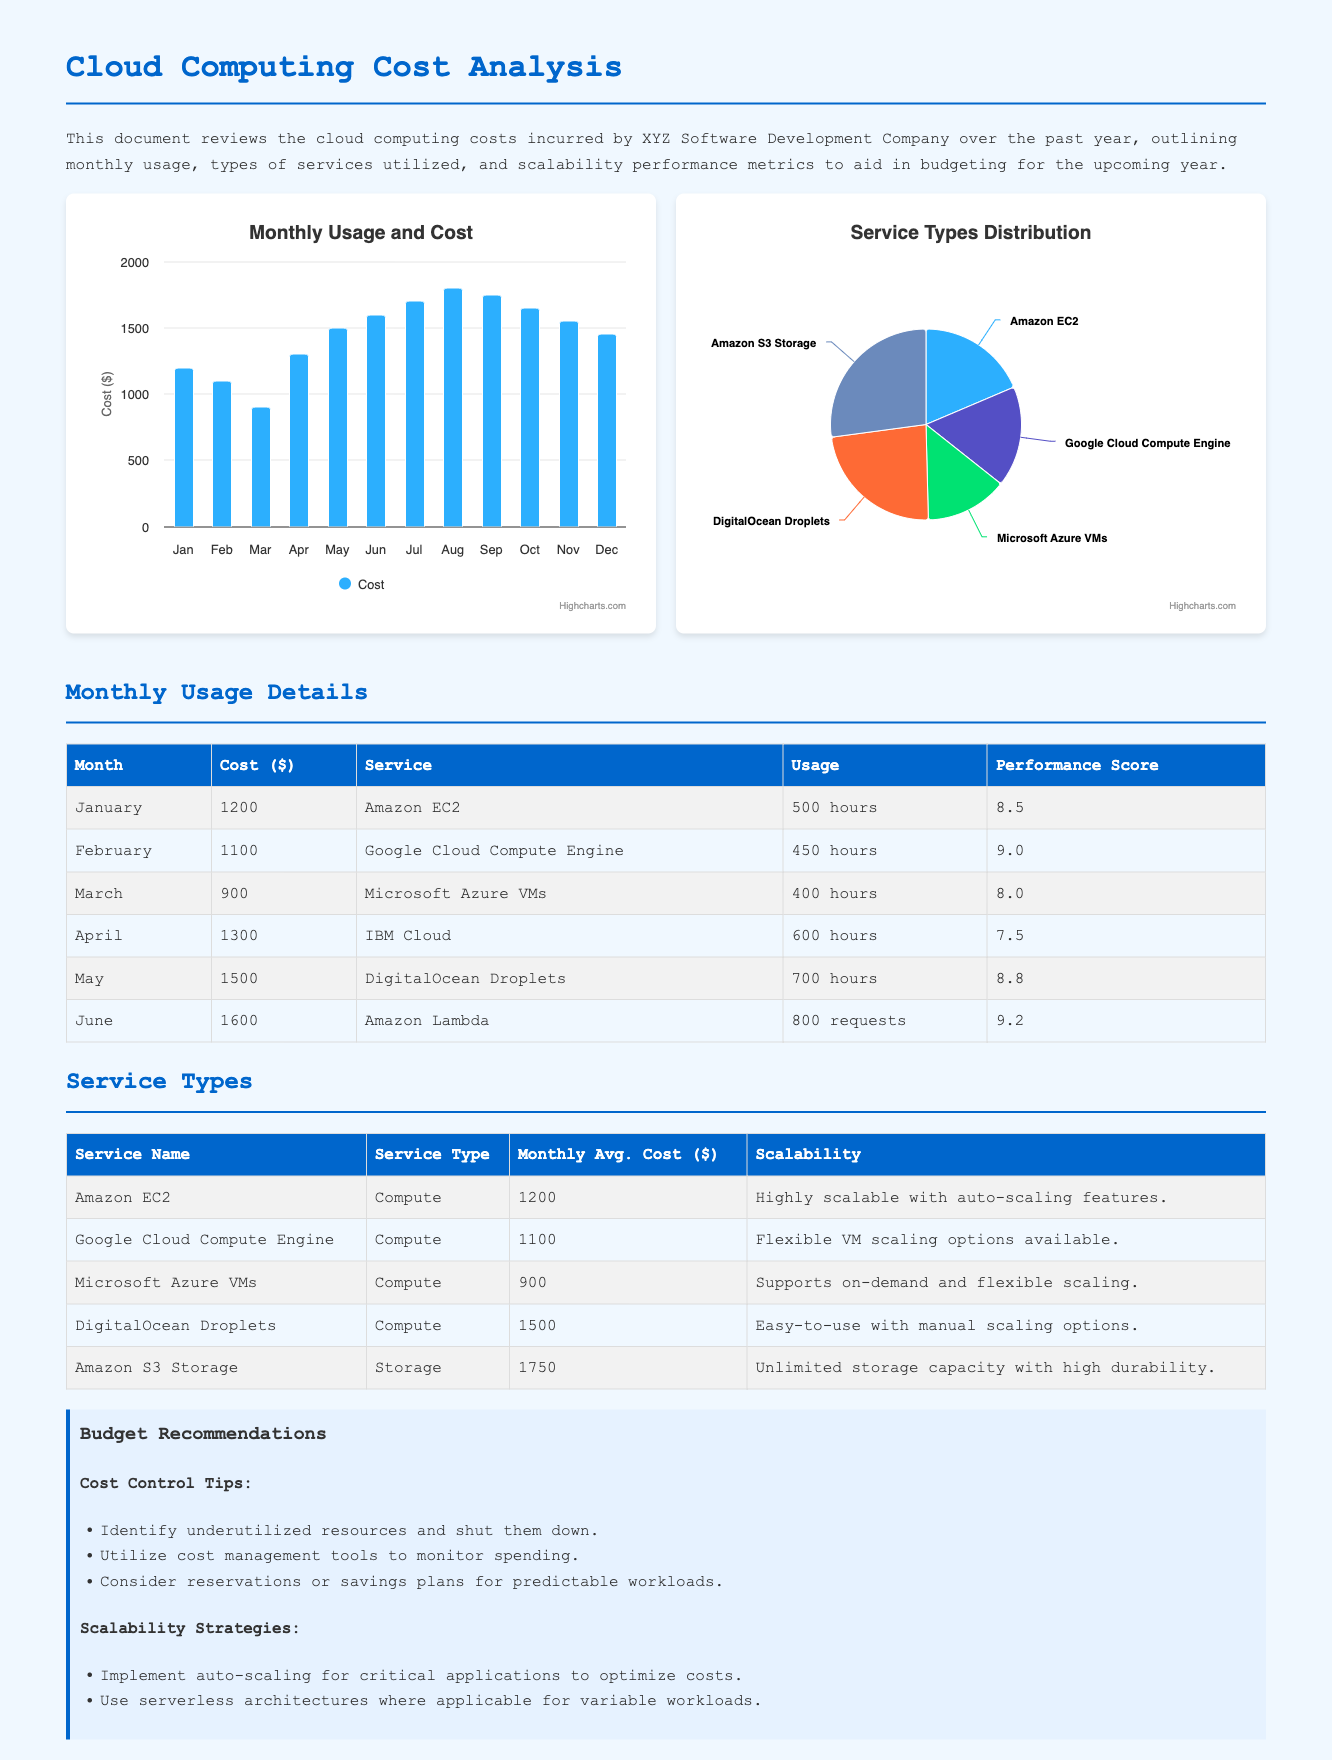What was the highest monthly cost? The highest monthly cost reported in the document is for June, which was $1600.
Answer: $1600 What service had the lowest performance score? The service with the lowest performance score in the monthly usage table is IBM Cloud, which had a score of 7.5.
Answer: IBM Cloud What was the average monthly cost for Amazon S3 Storage? The average monthly cost listed for Amazon S3 Storage in the service types table is $1750.
Answer: $1750 Which month had a cost of $1500? The month that had a cost of $1500 was May.
Answer: May What type of service is DigitalOcean Droplets categorized as? DigitalOcean Droplets is categorized as a Compute service type according to the service types table.
Answer: Compute What recommendation is given for cost control? One recommendation provided for cost control is to identify underutilized resources and shut them down.
Answer: Identify underutilized resources and shut them down Which service recorded the highest scalability rating? The service recorded with the highest scalability description is Amazon EC2, described as highly scalable with auto-scaling features.
Answer: Amazon EC2 What was the total cost for the first quarter (January to March)? The total cost for the first quarter is the sum of costs for January, February, and March, which is $1200 + $1100 + $900 = $3200.
Answer: $3200 What chart type is used for monthly usage? The chart type used for monthly usage is a column chart.
Answer: Column chart 